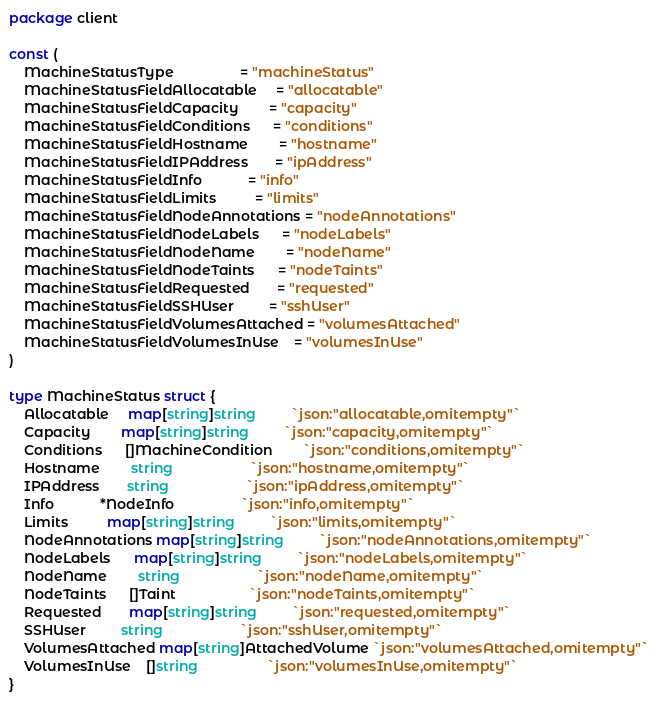Convert code to text. <code><loc_0><loc_0><loc_500><loc_500><_Go_>package client

const (
	MachineStatusType                 = "machineStatus"
	MachineStatusFieldAllocatable     = "allocatable"
	MachineStatusFieldCapacity        = "capacity"
	MachineStatusFieldConditions      = "conditions"
	MachineStatusFieldHostname        = "hostname"
	MachineStatusFieldIPAddress       = "ipAddress"
	MachineStatusFieldInfo            = "info"
	MachineStatusFieldLimits          = "limits"
	MachineStatusFieldNodeAnnotations = "nodeAnnotations"
	MachineStatusFieldNodeLabels      = "nodeLabels"
	MachineStatusFieldNodeName        = "nodeName"
	MachineStatusFieldNodeTaints      = "nodeTaints"
	MachineStatusFieldRequested       = "requested"
	MachineStatusFieldSSHUser         = "sshUser"
	MachineStatusFieldVolumesAttached = "volumesAttached"
	MachineStatusFieldVolumesInUse    = "volumesInUse"
)

type MachineStatus struct {
	Allocatable     map[string]string         `json:"allocatable,omitempty"`
	Capacity        map[string]string         `json:"capacity,omitempty"`
	Conditions      []MachineCondition        `json:"conditions,omitempty"`
	Hostname        string                    `json:"hostname,omitempty"`
	IPAddress       string                    `json:"ipAddress,omitempty"`
	Info            *NodeInfo                 `json:"info,omitempty"`
	Limits          map[string]string         `json:"limits,omitempty"`
	NodeAnnotations map[string]string         `json:"nodeAnnotations,omitempty"`
	NodeLabels      map[string]string         `json:"nodeLabels,omitempty"`
	NodeName        string                    `json:"nodeName,omitempty"`
	NodeTaints      []Taint                   `json:"nodeTaints,omitempty"`
	Requested       map[string]string         `json:"requested,omitempty"`
	SSHUser         string                    `json:"sshUser,omitempty"`
	VolumesAttached map[string]AttachedVolume `json:"volumesAttached,omitempty"`
	VolumesInUse    []string                  `json:"volumesInUse,omitempty"`
}
</code> 